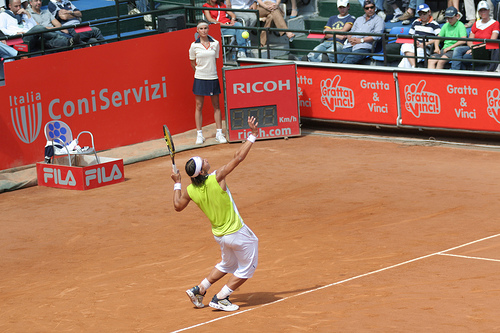Please transcribe the text information in this image. RICOH rich.com FILA FILA Vina Italia ConiServizi Km/h 888 nci & Otto Gratta &amp; Gratta Gratta Vinci &amp; Gratta 